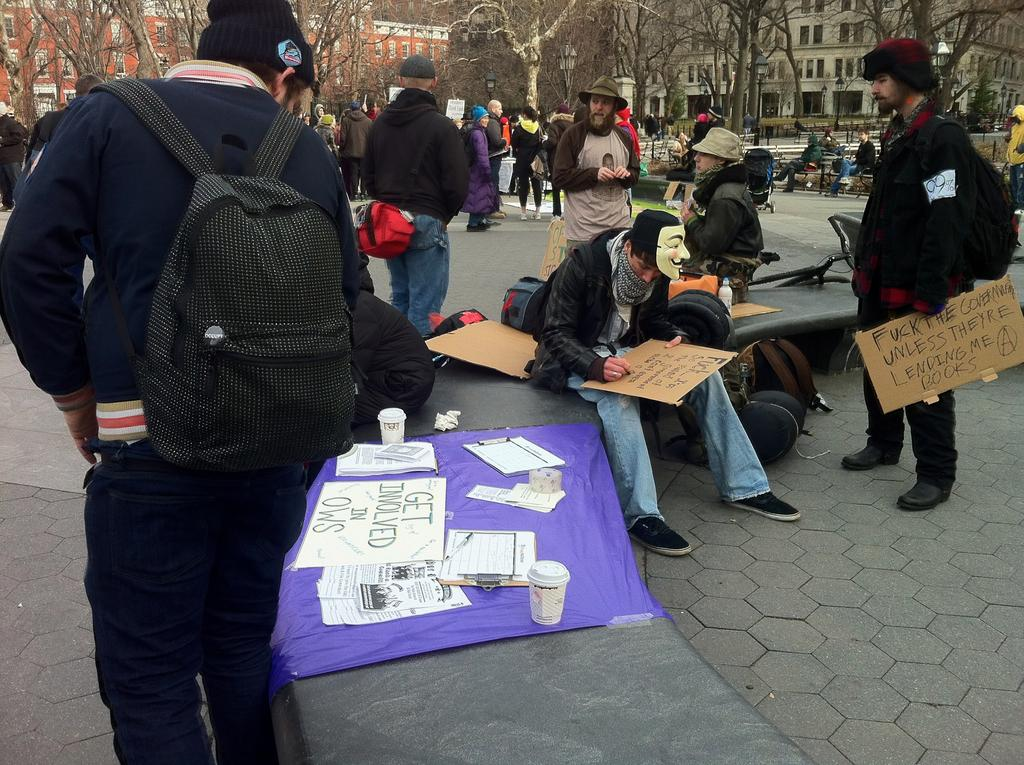What are the people in the image doing? Some people are standing, and some are sitting in the image. What objects can be seen in the image? Boards, glasses, and papers are visible in the image. What can be seen in the background of the image? Trees and buildings are visible in the background of the image. What type of music can be heard coming from the bells in the image? There are no bells present in the image, so it's not possible to determine what, if any, music might be heard. 